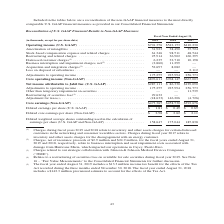From Jabil Circuit's financial document, Which fiscal years do charges relate to inventory and other assets charges for certain distressed customers in the networking and consumer wearables sectors? The document shows two values: 2019 and 2018. From the document: "(in thousands, except for per share data) 2019 2018 2017 (in thousands, except for per share data) 2019 2018 2017..." Also, What were the insurance proceeds for the fiscal year ended August 31, 2019? According to the financial document, $2.9 million. The relevant text states: "ustomer. (2) Charges, net of insurance proceeds of $2.9 million and $24.9 million, for the fiscal years ended August 31, 2019 and 2018, respectively, relate to busi..." Also, What were the Amortization of intangibles in 2019? According to the financial document, 31,923 (in thousands). The relevant text states: "Amortization of intangibles . 31,923 38,490 35,524 Stock-based compensation expense and related charges . 61,346 98,511 48,544 Restructu..." Also, can you calculate: What was the change in Restructuring and related charges between 2018 and 2019? Based on the calculation: 25,914-36,902, the result is -10988 (in thousands). This is based on the information: "48,544 Restructuring and related charges . 25,914 36,902 160,395 Distressed customer charges (1) . 6,235 32,710 10,198 Business interruption and impairment 98,511 48,544 Restructuring and related char..." The key data points involved are: 25,914, 36,902. Also, How many years did Operating income (U.S. GAAP) exceed $500,000 thousand? Counting the relevant items in the document: 2019, 2018, I find 2 instances. The key data points involved are: 2018, 2019. Also, can you calculate: What was the percentage change in Net income attributable to Jabil Inc.(U.S.GAAP) between 2018 and 2019? To answer this question, I need to perform calculations using the financial data. The calculation is: ($287,111-$86,330)/$86,330, which equals 232.57 (percentage). This is based on the information: "income attributable to Jabil Inc. (U.S. GAAP) . $287,111 $ 86,330 $129,090 Adjustments to operating income . 175,255 225,994 256,773 Other than temporary im tributable to Jabil Inc. (U.S. GAAP) . $287..." The key data points involved are: 287,111, 86,330. 